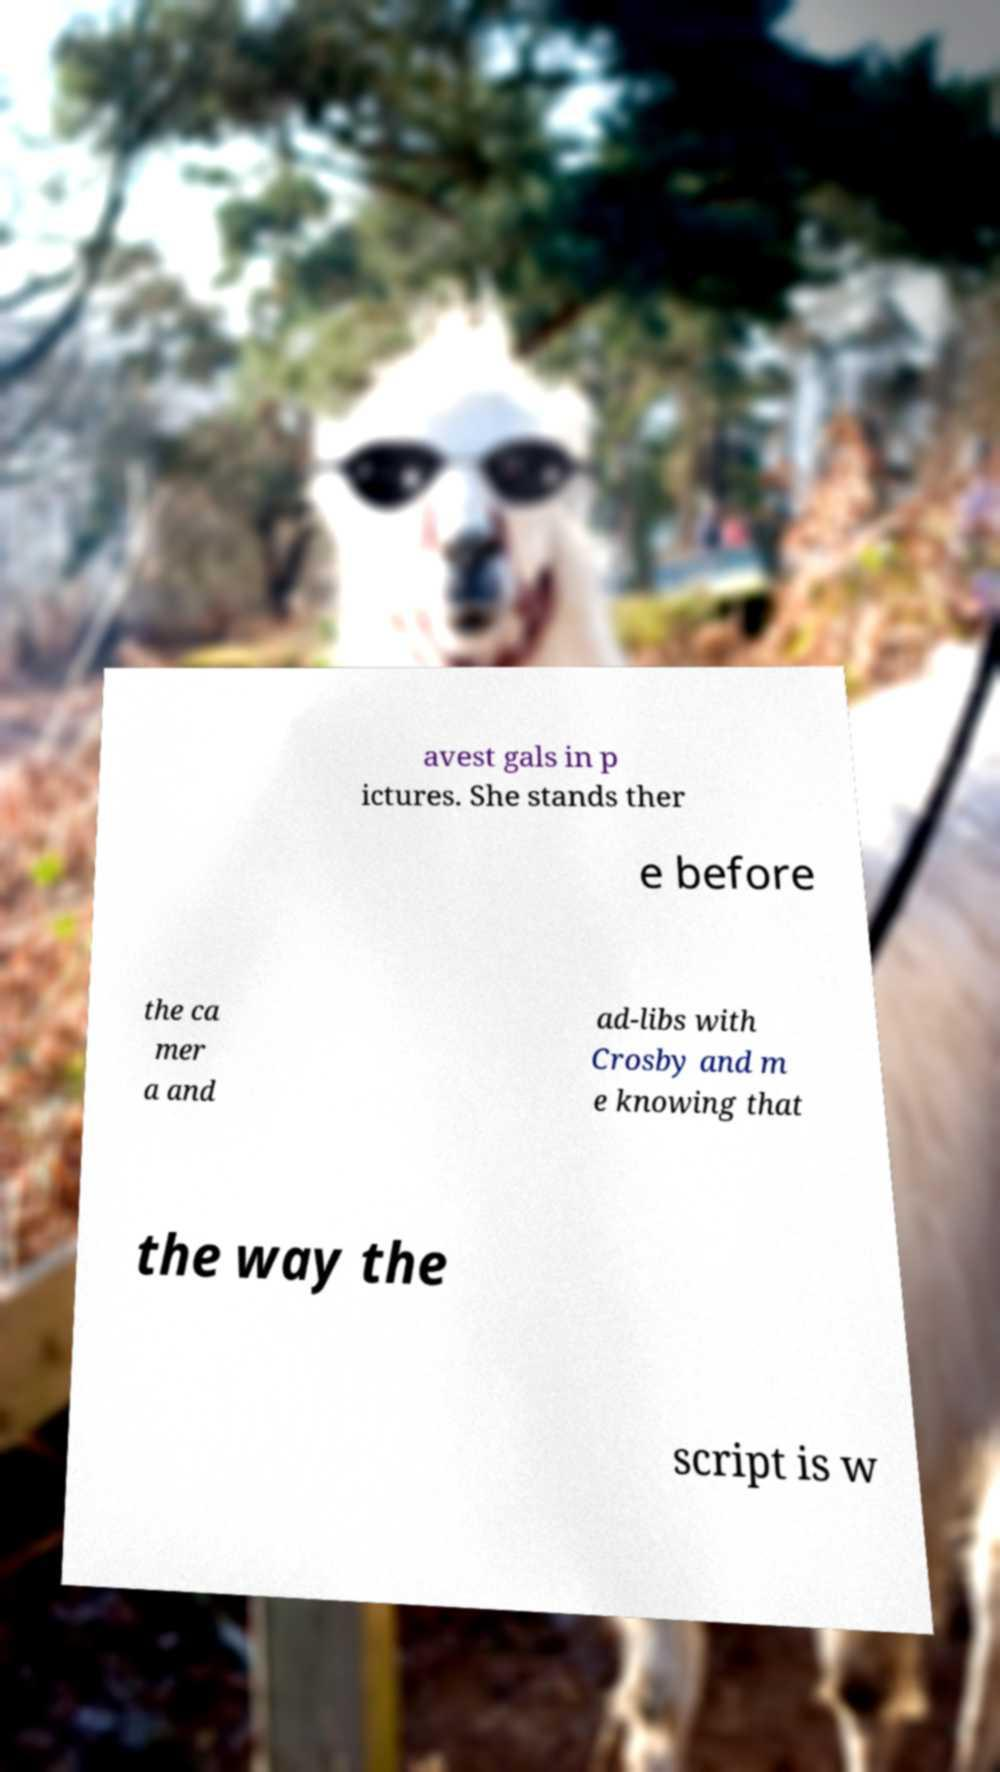Can you read and provide the text displayed in the image?This photo seems to have some interesting text. Can you extract and type it out for me? avest gals in p ictures. She stands ther e before the ca mer a and ad-libs with Crosby and m e knowing that the way the script is w 